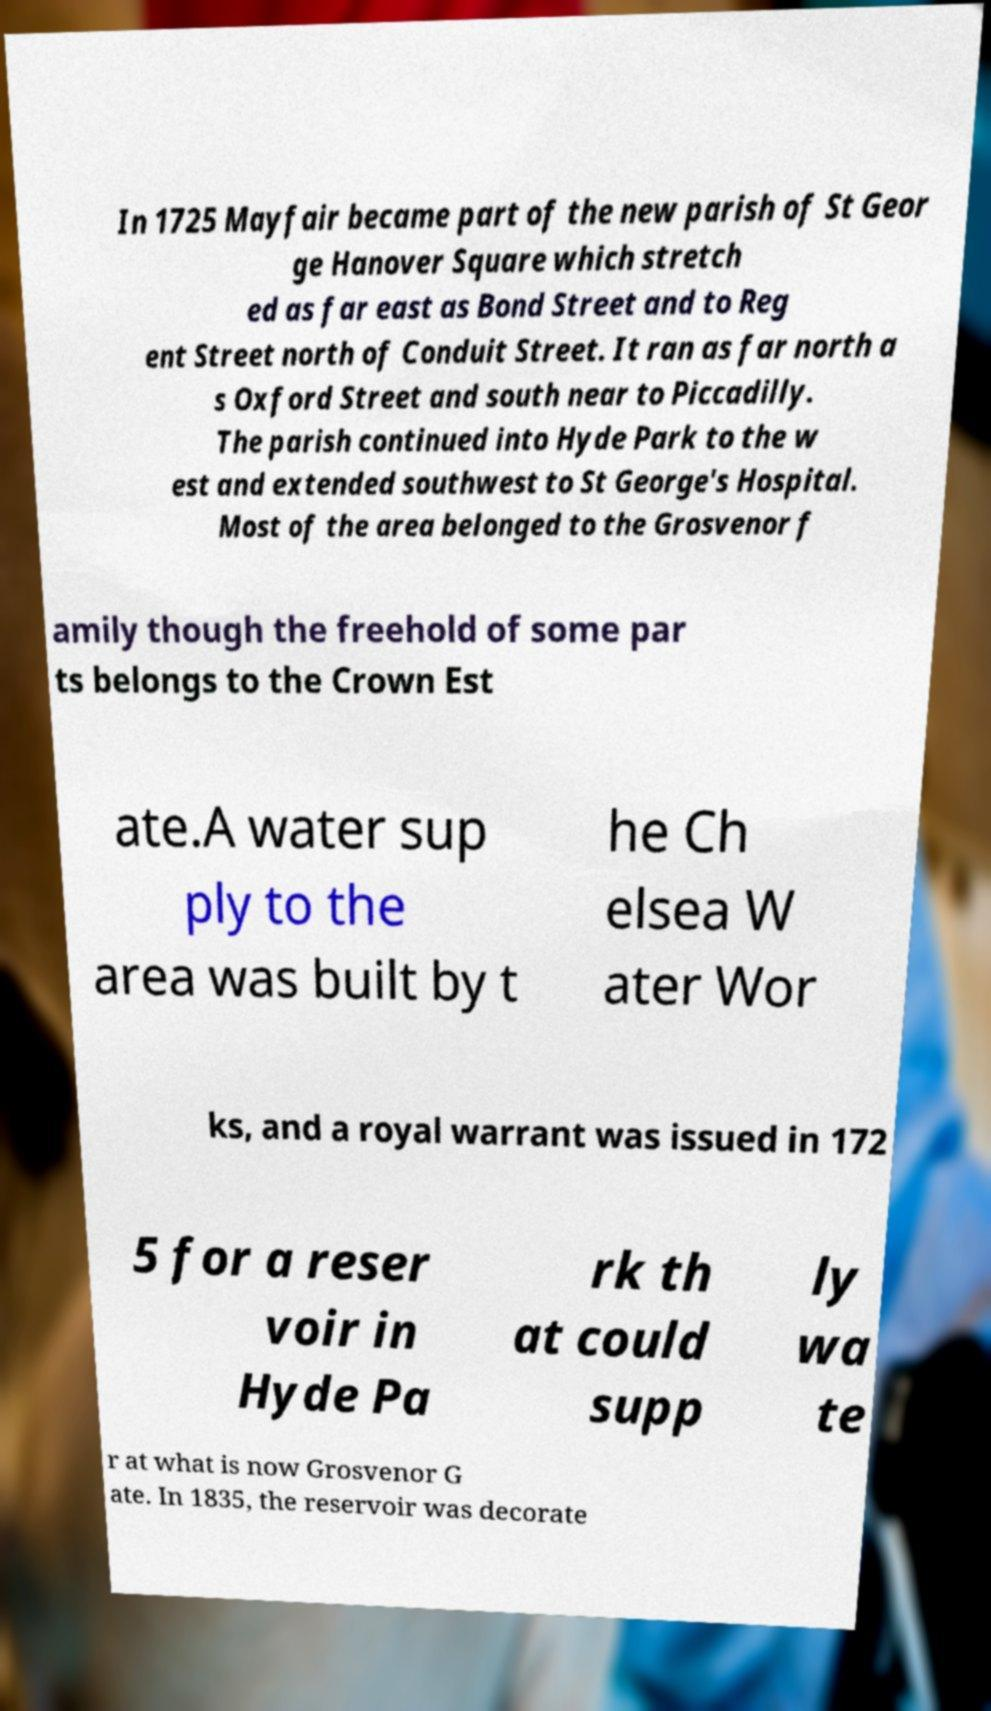Please read and relay the text visible in this image. What does it say? In 1725 Mayfair became part of the new parish of St Geor ge Hanover Square which stretch ed as far east as Bond Street and to Reg ent Street north of Conduit Street. It ran as far north a s Oxford Street and south near to Piccadilly. The parish continued into Hyde Park to the w est and extended southwest to St George's Hospital. Most of the area belonged to the Grosvenor f amily though the freehold of some par ts belongs to the Crown Est ate.A water sup ply to the area was built by t he Ch elsea W ater Wor ks, and a royal warrant was issued in 172 5 for a reser voir in Hyde Pa rk th at could supp ly wa te r at what is now Grosvenor G ate. In 1835, the reservoir was decorate 